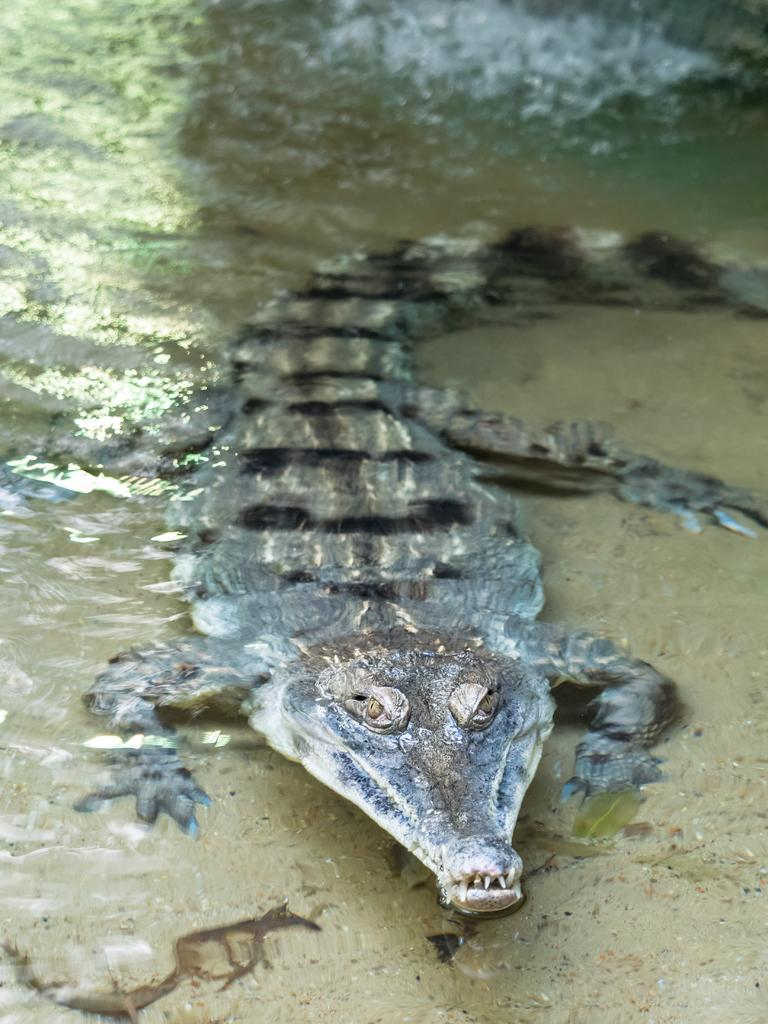What animal is present in the image? There is a crocodile in the image. What is the color of the crocodile? The crocodile is brown in color. Where is the crocodile located in the image? The crocodile is in the water and located in the middle of the image. What type of loaf is being argued over by the crocodile and a visitor in the image? There is no loaf or visitor present in the image; it only features a brown crocodile in the water. 